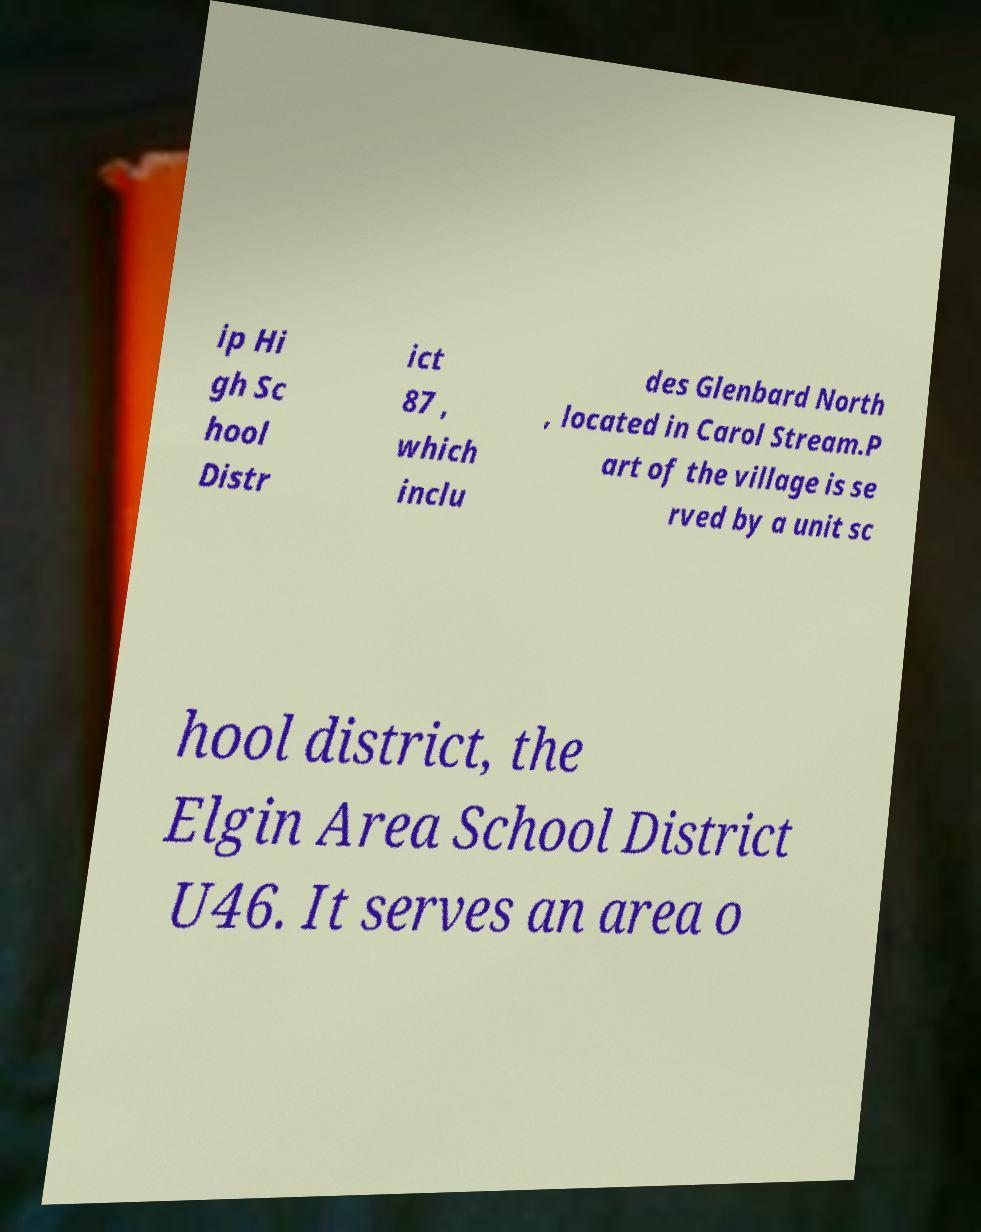What messages or text are displayed in this image? I need them in a readable, typed format. ip Hi gh Sc hool Distr ict 87 , which inclu des Glenbard North , located in Carol Stream.P art of the village is se rved by a unit sc hool district, the Elgin Area School District U46. It serves an area o 